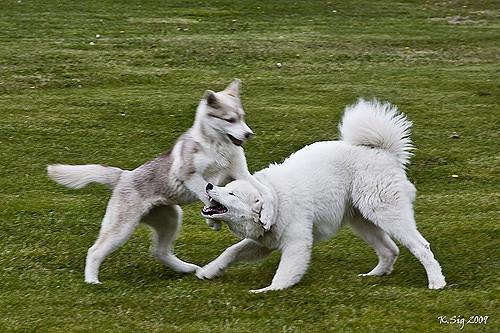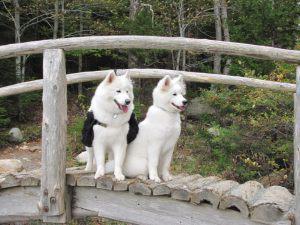The first image is the image on the left, the second image is the image on the right. Considering the images on both sides, is "Each image contains exactly one fluffy dog." valid? Answer yes or no. No. The first image is the image on the left, the second image is the image on the right. For the images displayed, is the sentence "Both images contain a single dog." factually correct? Answer yes or no. No. 